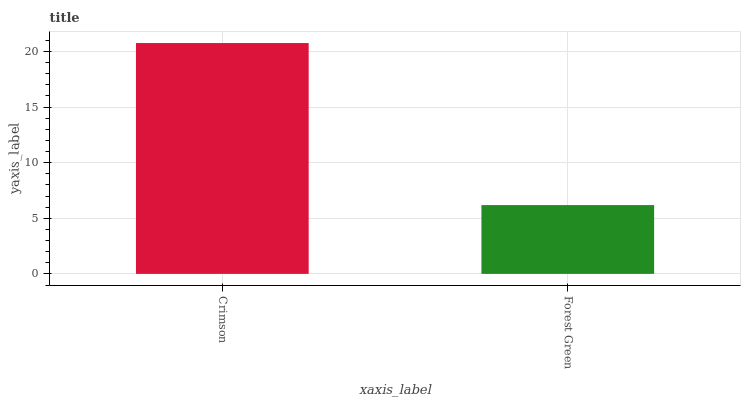Is Forest Green the minimum?
Answer yes or no. Yes. Is Crimson the maximum?
Answer yes or no. Yes. Is Forest Green the maximum?
Answer yes or no. No. Is Crimson greater than Forest Green?
Answer yes or no. Yes. Is Forest Green less than Crimson?
Answer yes or no. Yes. Is Forest Green greater than Crimson?
Answer yes or no. No. Is Crimson less than Forest Green?
Answer yes or no. No. Is Crimson the high median?
Answer yes or no. Yes. Is Forest Green the low median?
Answer yes or no. Yes. Is Forest Green the high median?
Answer yes or no. No. Is Crimson the low median?
Answer yes or no. No. 